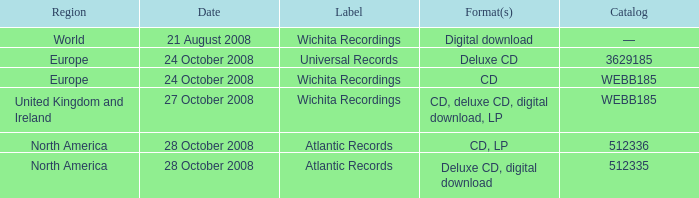Which formats have a region of Europe and Catalog value of WEBB185? CD. 